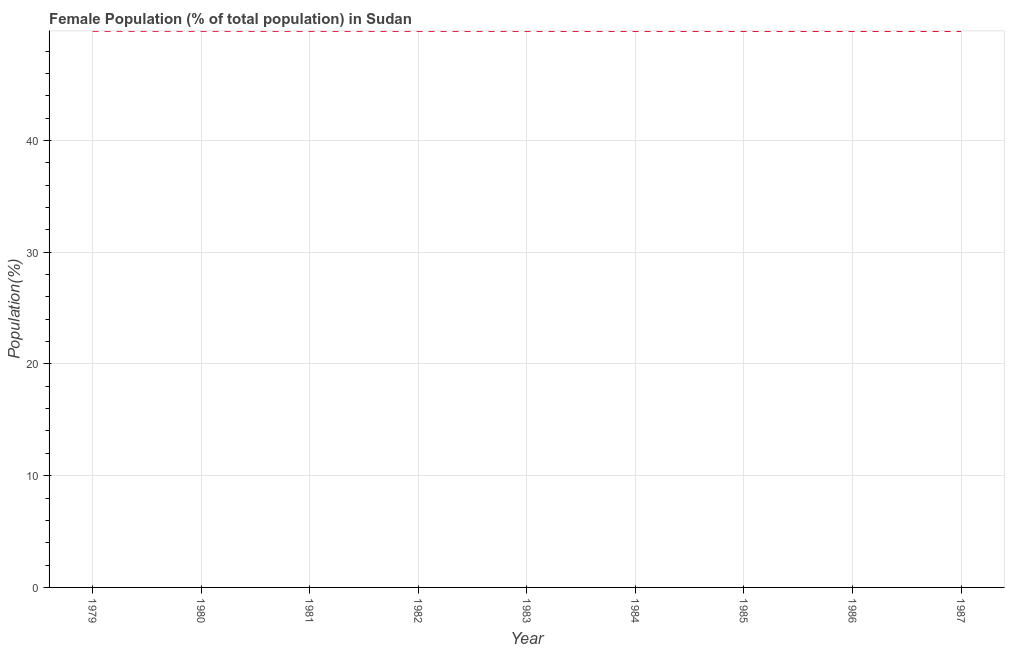What is the female population in 1984?
Ensure brevity in your answer.  49.8. Across all years, what is the maximum female population?
Make the answer very short. 49.81. Across all years, what is the minimum female population?
Your answer should be compact. 49.79. In which year was the female population maximum?
Provide a succinct answer. 1979. In which year was the female population minimum?
Ensure brevity in your answer.  1987. What is the sum of the female population?
Keep it short and to the point. 448.19. What is the difference between the female population in 1982 and 1985?
Your response must be concise. 0.01. What is the average female population per year?
Your response must be concise. 49.8. What is the median female population?
Offer a terse response. 49.8. In how many years, is the female population greater than 4 %?
Make the answer very short. 9. What is the ratio of the female population in 1979 to that in 1981?
Your answer should be very brief. 1. Is the difference between the female population in 1985 and 1986 greater than the difference between any two years?
Offer a very short reply. No. What is the difference between the highest and the second highest female population?
Provide a short and direct response. 0. Is the sum of the female population in 1979 and 1985 greater than the maximum female population across all years?
Give a very brief answer. Yes. What is the difference between the highest and the lowest female population?
Give a very brief answer. 0.02. How many lines are there?
Offer a very short reply. 1. How many years are there in the graph?
Provide a succinct answer. 9. What is the difference between two consecutive major ticks on the Y-axis?
Provide a short and direct response. 10. Does the graph contain any zero values?
Your response must be concise. No. Does the graph contain grids?
Ensure brevity in your answer.  Yes. What is the title of the graph?
Your answer should be very brief. Female Population (% of total population) in Sudan. What is the label or title of the X-axis?
Provide a succinct answer. Year. What is the label or title of the Y-axis?
Provide a succinct answer. Population(%). What is the Population(%) in 1979?
Offer a very short reply. 49.81. What is the Population(%) in 1980?
Provide a short and direct response. 49.8. What is the Population(%) in 1981?
Offer a very short reply. 49.8. What is the Population(%) of 1982?
Your answer should be very brief. 49.8. What is the Population(%) of 1983?
Your answer should be compact. 49.8. What is the Population(%) in 1984?
Keep it short and to the point. 49.8. What is the Population(%) of 1985?
Ensure brevity in your answer.  49.8. What is the Population(%) in 1986?
Your answer should be compact. 49.79. What is the Population(%) in 1987?
Provide a short and direct response. 49.79. What is the difference between the Population(%) in 1979 and 1980?
Make the answer very short. 0. What is the difference between the Population(%) in 1979 and 1981?
Make the answer very short. 0. What is the difference between the Population(%) in 1979 and 1982?
Offer a very short reply. 0.01. What is the difference between the Population(%) in 1979 and 1983?
Offer a terse response. 0.01. What is the difference between the Population(%) in 1979 and 1984?
Ensure brevity in your answer.  0.01. What is the difference between the Population(%) in 1979 and 1985?
Ensure brevity in your answer.  0.01. What is the difference between the Population(%) in 1979 and 1986?
Provide a short and direct response. 0.01. What is the difference between the Population(%) in 1979 and 1987?
Offer a very short reply. 0.02. What is the difference between the Population(%) in 1980 and 1981?
Your response must be concise. 0. What is the difference between the Population(%) in 1980 and 1982?
Provide a succinct answer. 0. What is the difference between the Population(%) in 1980 and 1983?
Keep it short and to the point. 0.01. What is the difference between the Population(%) in 1980 and 1984?
Offer a very short reply. 0.01. What is the difference between the Population(%) in 1980 and 1985?
Keep it short and to the point. 0.01. What is the difference between the Population(%) in 1980 and 1986?
Offer a very short reply. 0.01. What is the difference between the Population(%) in 1980 and 1987?
Your response must be concise. 0.01. What is the difference between the Population(%) in 1981 and 1982?
Provide a succinct answer. 0. What is the difference between the Population(%) in 1981 and 1983?
Provide a short and direct response. 0. What is the difference between the Population(%) in 1981 and 1984?
Your response must be concise. 0.01. What is the difference between the Population(%) in 1981 and 1985?
Give a very brief answer. 0.01. What is the difference between the Population(%) in 1981 and 1986?
Give a very brief answer. 0.01. What is the difference between the Population(%) in 1981 and 1987?
Your response must be concise. 0.01. What is the difference between the Population(%) in 1982 and 1983?
Your answer should be very brief. 0. What is the difference between the Population(%) in 1982 and 1984?
Provide a short and direct response. 0. What is the difference between the Population(%) in 1982 and 1985?
Your answer should be compact. 0.01. What is the difference between the Population(%) in 1982 and 1986?
Ensure brevity in your answer.  0.01. What is the difference between the Population(%) in 1982 and 1987?
Offer a very short reply. 0.01. What is the difference between the Population(%) in 1983 and 1984?
Provide a succinct answer. 0. What is the difference between the Population(%) in 1983 and 1985?
Offer a terse response. 0. What is the difference between the Population(%) in 1983 and 1986?
Your answer should be compact. 0.01. What is the difference between the Population(%) in 1983 and 1987?
Your answer should be very brief. 0.01. What is the difference between the Population(%) in 1984 and 1985?
Make the answer very short. 0. What is the difference between the Population(%) in 1984 and 1986?
Ensure brevity in your answer.  0. What is the difference between the Population(%) in 1984 and 1987?
Your answer should be very brief. 0. What is the difference between the Population(%) in 1985 and 1986?
Provide a succinct answer. 0. What is the difference between the Population(%) in 1985 and 1987?
Keep it short and to the point. 0. What is the difference between the Population(%) in 1986 and 1987?
Your answer should be very brief. 0. What is the ratio of the Population(%) in 1979 to that in 1983?
Provide a succinct answer. 1. What is the ratio of the Population(%) in 1979 to that in 1985?
Give a very brief answer. 1. What is the ratio of the Population(%) in 1980 to that in 1981?
Offer a terse response. 1. What is the ratio of the Population(%) in 1980 to that in 1983?
Offer a terse response. 1. What is the ratio of the Population(%) in 1980 to that in 1984?
Make the answer very short. 1. What is the ratio of the Population(%) in 1980 to that in 1985?
Your answer should be compact. 1. What is the ratio of the Population(%) in 1981 to that in 1982?
Provide a succinct answer. 1. What is the ratio of the Population(%) in 1981 to that in 1983?
Ensure brevity in your answer.  1. What is the ratio of the Population(%) in 1982 to that in 1983?
Provide a short and direct response. 1. What is the ratio of the Population(%) in 1982 to that in 1984?
Your answer should be compact. 1. What is the ratio of the Population(%) in 1982 to that in 1985?
Keep it short and to the point. 1. What is the ratio of the Population(%) in 1983 to that in 1984?
Your answer should be compact. 1. What is the ratio of the Population(%) in 1983 to that in 1987?
Your answer should be very brief. 1. What is the ratio of the Population(%) in 1985 to that in 1986?
Give a very brief answer. 1. 